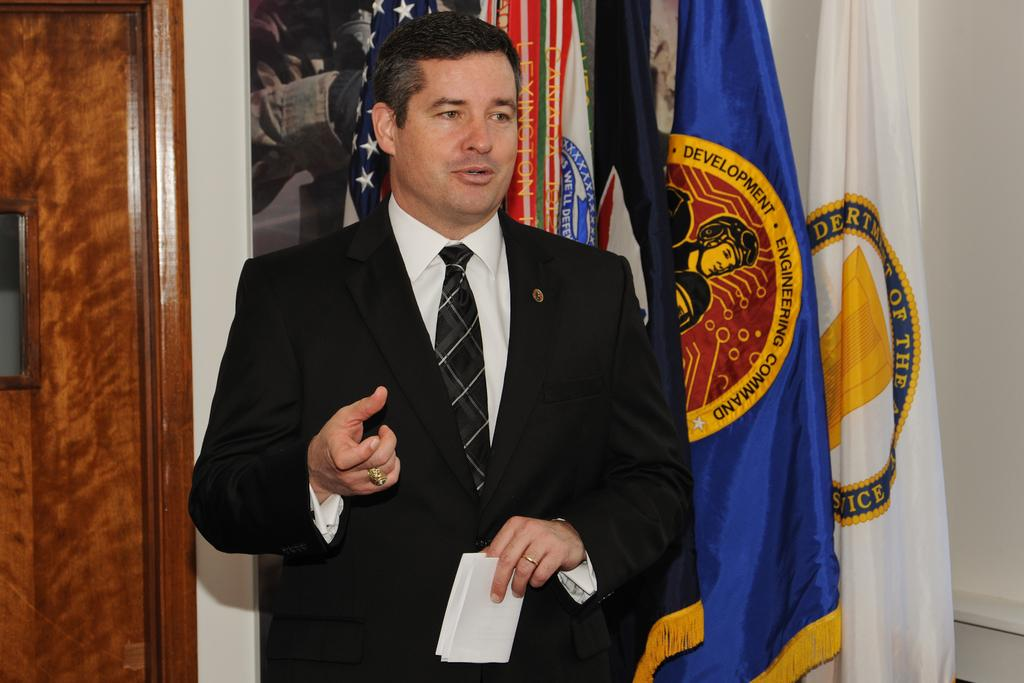<image>
Render a clear and concise summary of the photo. Man standing in front of a flag that says "Development". 